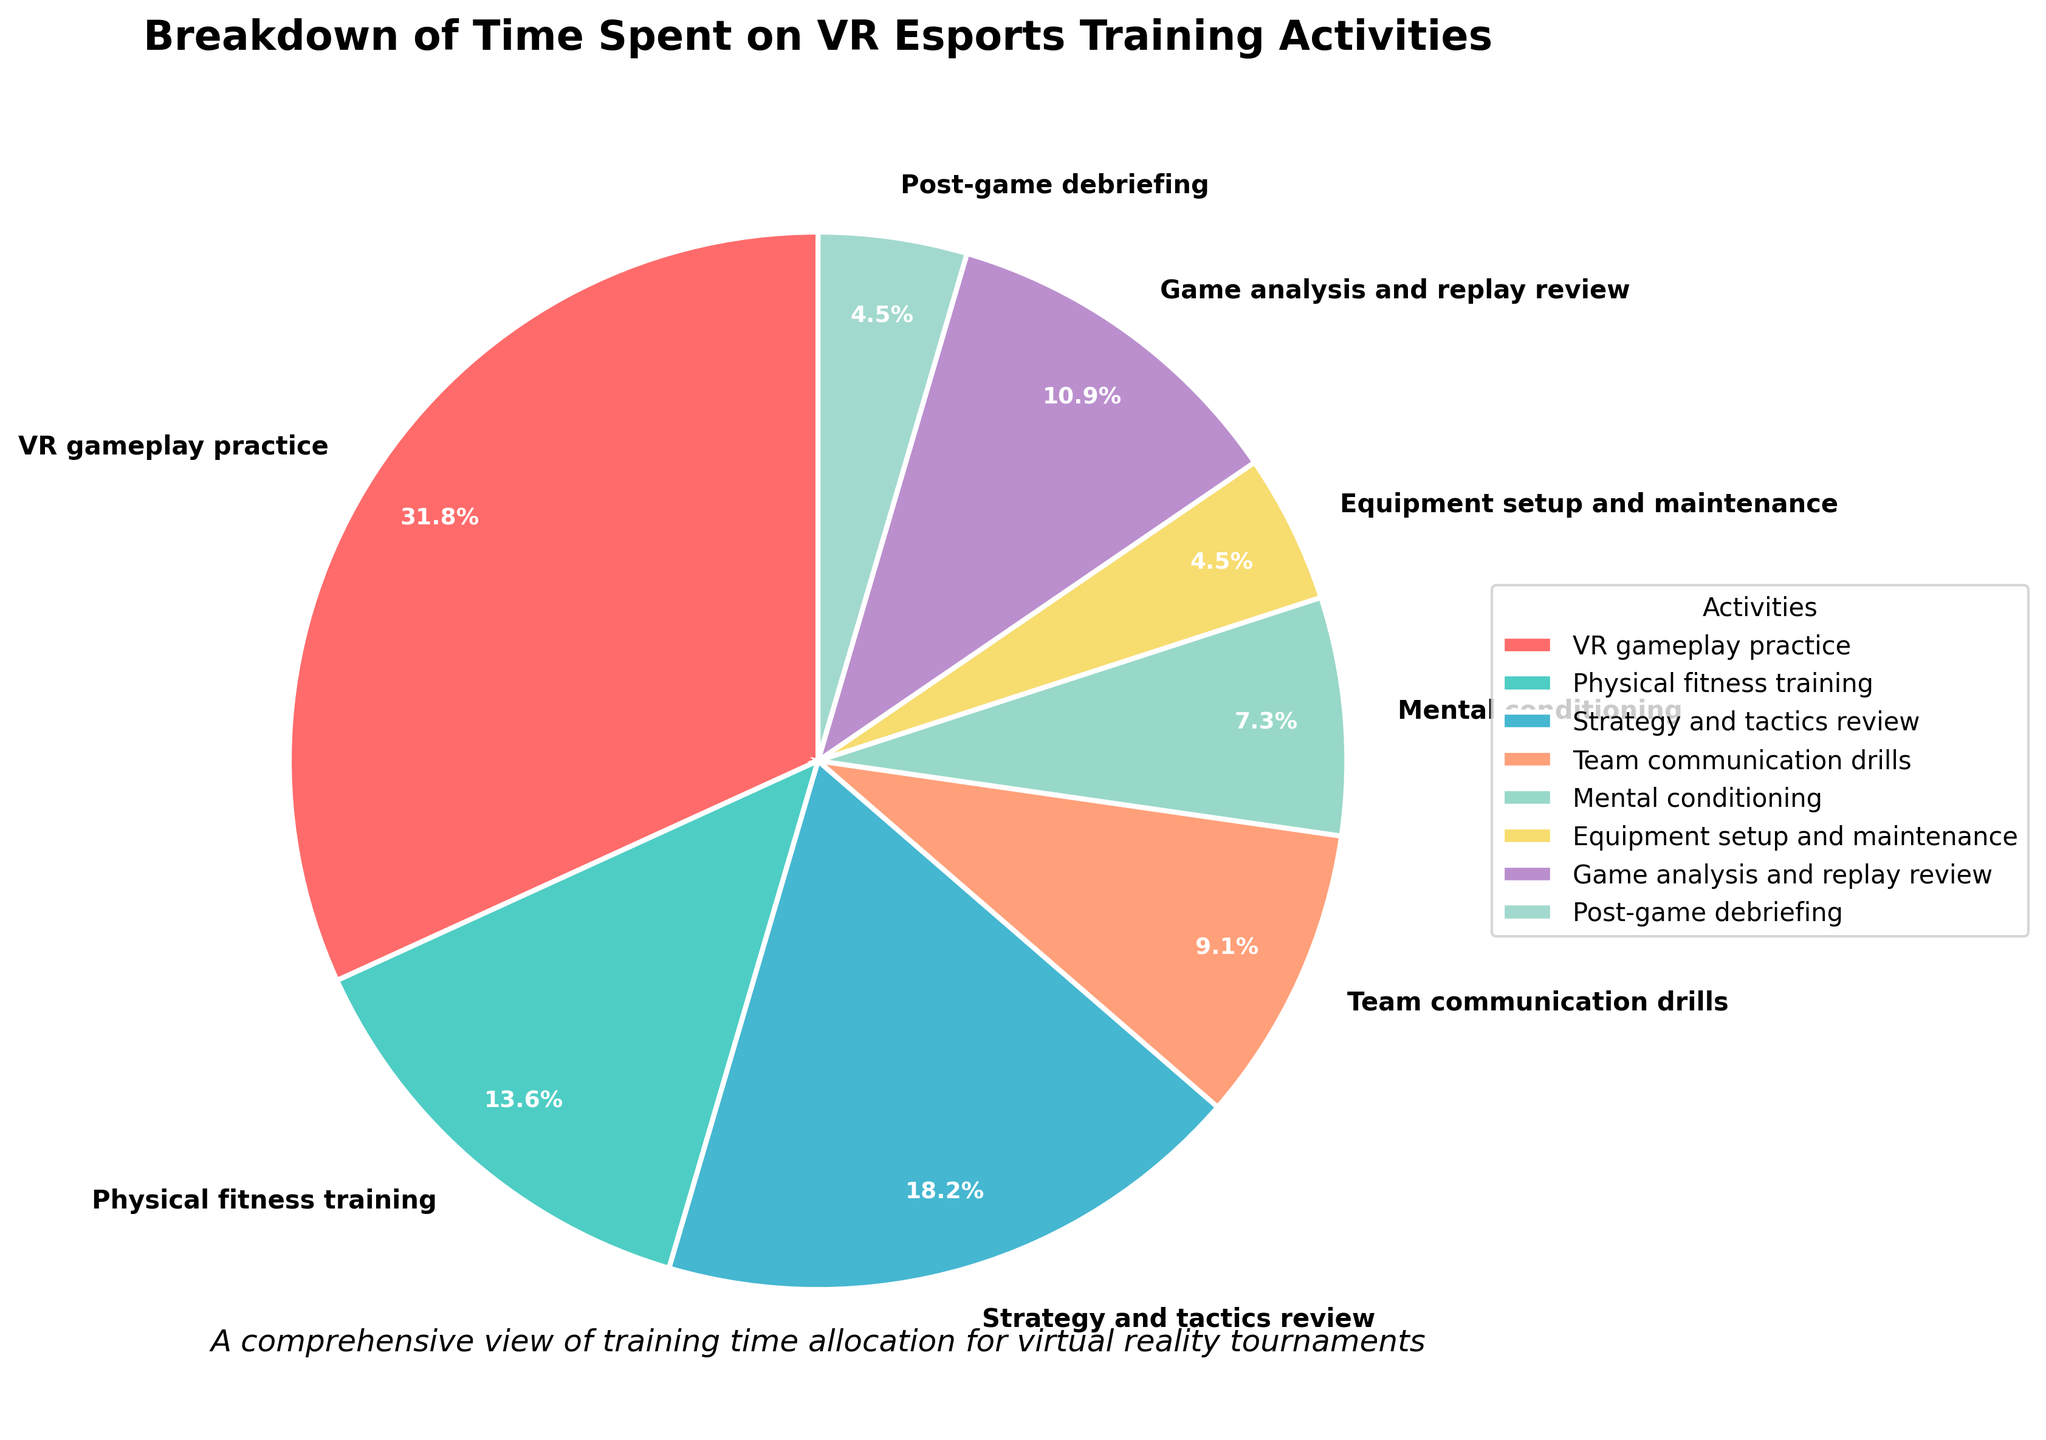What percentage of time is spent on 'Game analysis and replay review'? Locate the slice labeled 'Game analysis and replay review' and read the percentage printed on it.
Answer: 12% Which activity takes up the largest portion of time? Identify the slice with the largest area, which is labeled 'VR gameplay practice', and note its percentage.
Answer: VR gameplay practice How much more time is spent on 'Strategy and tactics review' compared to 'Equipment setup and maintenance'? Subtract the percentage of 'Equipment setup and maintenance' from the percentage of 'Strategy and tactics review': 20% - 5%.
Answer: 15% Which activity is given the least amount of time? Find the smallest slice, which is labeled 'Equipment setup and maintenance' and 'Post-game debriefing', both are equal.
Answer: Equipment setup and maintenance and Post-game debriefing What is the combined percentage of time spent on 'Physical fitness training' and 'Mental conditioning'? Add the percentages for 'Physical fitness training' (15%) and 'Mental conditioning' (8%): 15% + 8%.
Answer: 23% How does the time allocated to 'Team communication drills' compare to 'Game analysis and replay review'? Compare the percentages: 'Team communication drills' is 10%, 'Game analysis and replay review' is 12%. Since 10% < 12%, 'Game analysis and replay review' gets more time.
Answer: Less What portion of the total time is dedicated to activities related to physical and mental preparation (Physical fitness training, Mental conditioning)? Add 'Physical fitness training' (15%), and 'Mental conditioning' (8%): 15% + 8%.
Answer: 23% Which activity takes up more time, 'Strategy and tactics review' or 'Team communication drills'? Compare the percentages: 'Strategy and tactics review' (20%) and 'Team communication drills' (10%). Since 20% > 10%, 'Strategy and tactics review' takes up more time.
Answer: Strategy and tactics review If the percentages of 'Equipment setup and maintenance' and 'Post-game debriefing' were combined into one category, what would be the new percentage? Add the percentages of these two activities: 5% + 5%.
Answer: 10% 